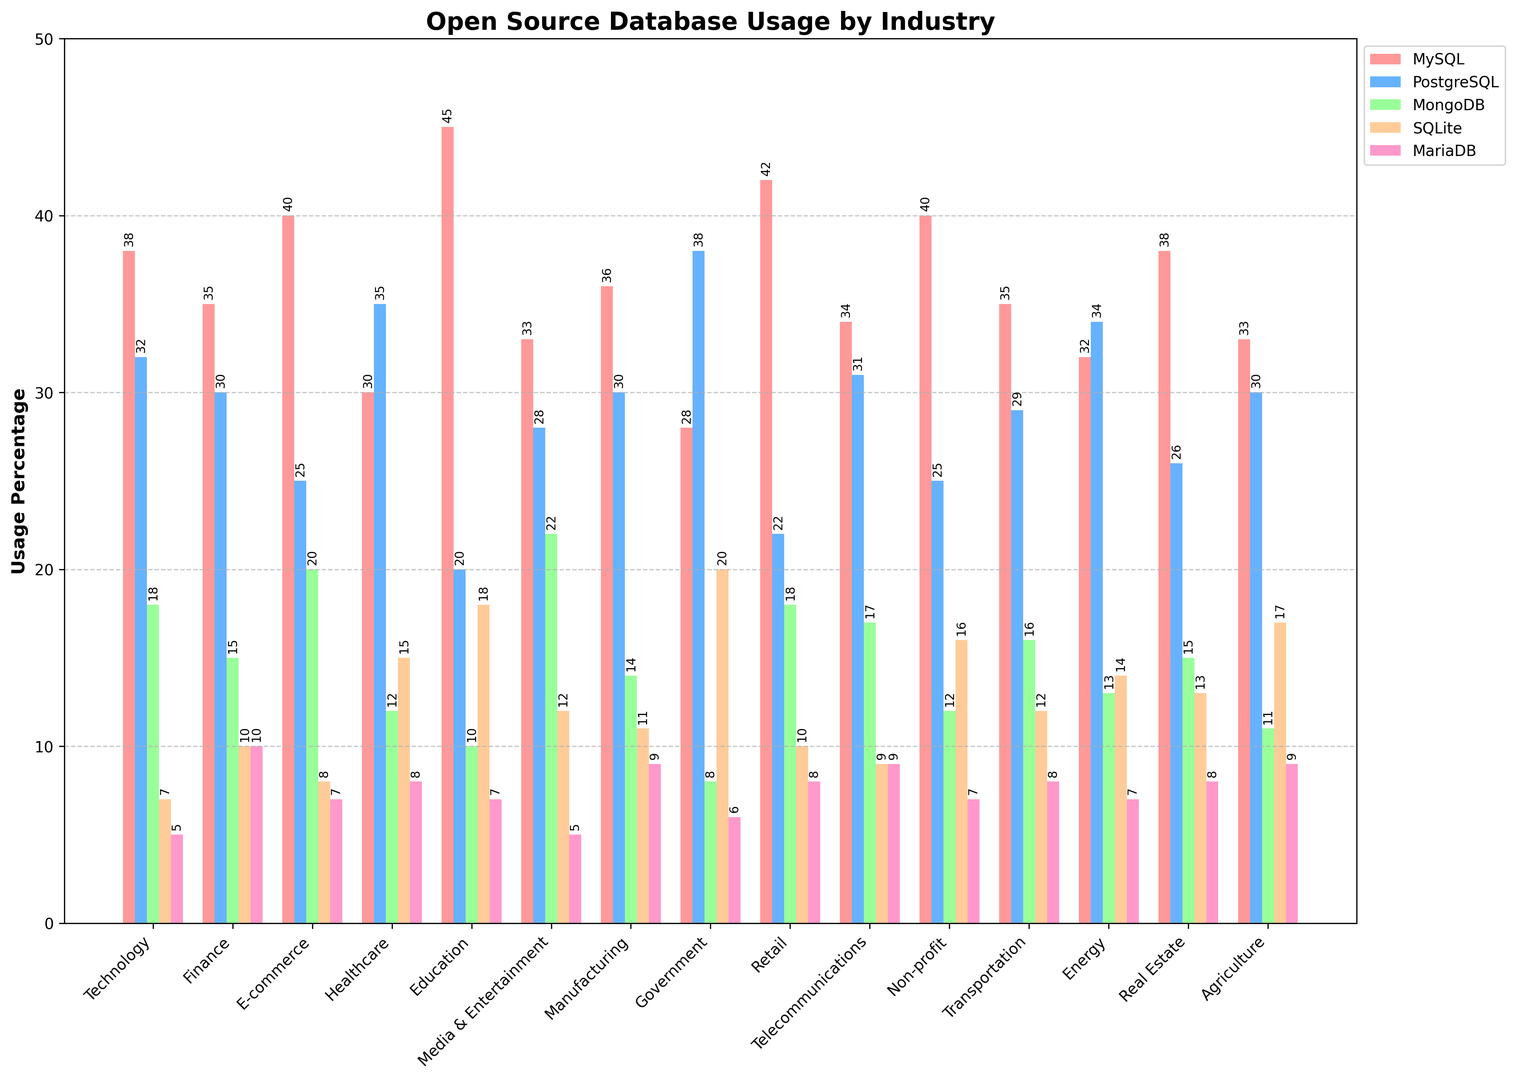Which industry has the highest usage of MySQL? Look at the height of the bars representing MySQL in each industry. The industry with the tallest bar is Education.
Answer: Education What is the difference in PostgreSQL usage between Technology and Government sectors? Look at the height of the PostgreSQL bars for Technology and Government. Technology has 32%, and Government has 38%. The difference is 38 - 32 = 6%.
Answer: 6% Which industry favors MongoDB the most? Observe the heights of the MongoDB bars across all industries. The industry with the highest bar is Media & Entertainment with 22%.
Answer: Media & Entertainment What's the combined percentage of SQLite usage for Healthcare and Education? Look at the height of the SQLite bars for Healthcare and Education. Healthcare has 15%, and Education has 18%. The combined percentage is 15 + 18 = 33%.
Answer: 33% How much more popular is MySQL than MariaDB in the Retail industry? Look at the heights of the MySQL and MariaDB bars in the Retail industry. MySQL has 42%, and MariaDB has 8%. The difference is 42 - 8 = 34%.
Answer: 34% In which industry is PostgreSQL use greater than MySQL use? Compare the heights of the PostgreSQL and MySQL bars in each industry. PostgreSQL is greater than MySQL in the Government sector.
Answer: Government Calculate the average usage of MongoDB across all industries. Sum the percentages of MongoDB for all industries and divide by the number of industries: (18+15+20+12+10+22+14+8+18+17+12+16+13+15+11) / 15 = 213/15 = 14.2%.
Answer: 14.2% Which database has the lowest usage in the Education sector? Compare the heights of all bars in the Education sector. MongoDB has the lowest usage at 10%.
Answer: MongoDB How much more does the Technology sector use MySQL compared to SQLite? Look at the height of the MySQL and SQLite bars in the Technology sector. MySQL has 38%, and SQLite has 7%. The difference is 38 - 7 = 31%.
Answer: 31% Which database is used more in the E-commerce industry, PostgreSQL or MariaDB? Compare the heights of PostgreSQL and MariaDB bars in the E-commerce industry. PostgreSQL has 25%, and MariaDB has 7%. Therefore, PostgreSQL is used more.
Answer: PostgreSQL 